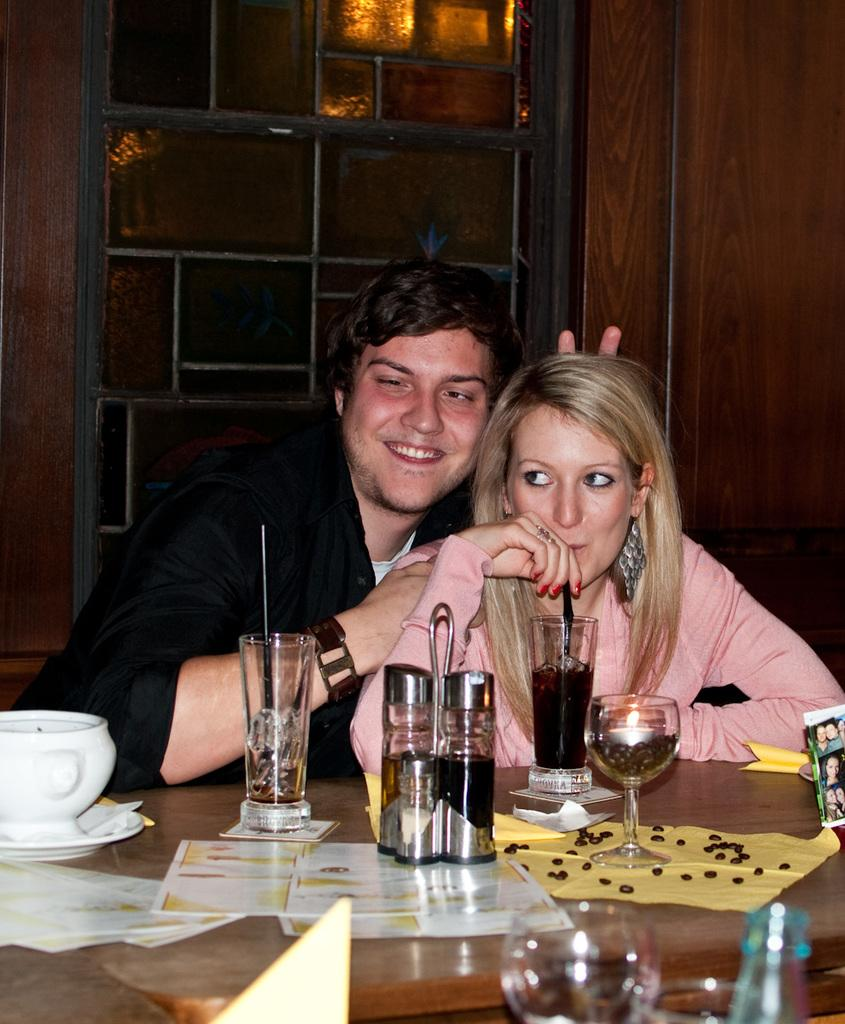How many people are in the image? There are two people in the image, a man and a woman. What are the man and woman doing in the image? The man and woman are sitting in the image. What objects can be seen on the table in front of them? There is a cup, plate, glasses, bottles, and papers on the table in front of them. What is the facial expression of the man in the image? The man is smiling in the image. What is visible behind the man and woman? There is a window behind them. Can you tell me how many bees are buzzing around the man's knee in the image? There are no bees present in the image, and the man's knee is not mentioned in the provided facts. 